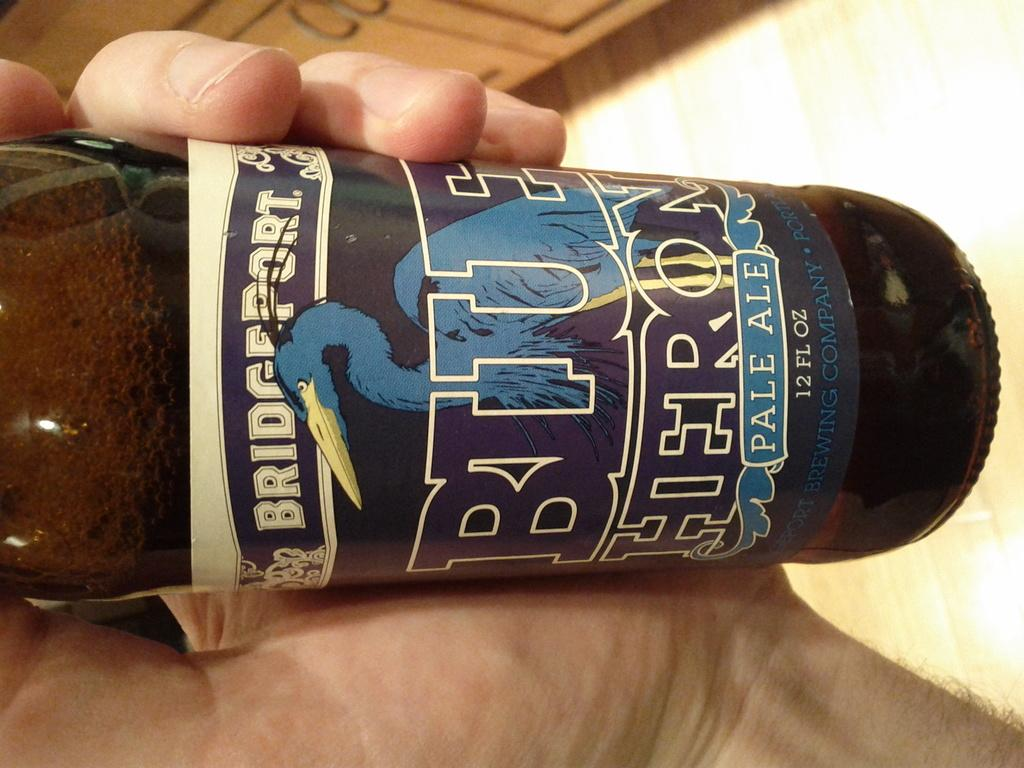<image>
Create a compact narrative representing the image presented. A person is holding a bottle of Bridgeport Blue Heron pale ale. 